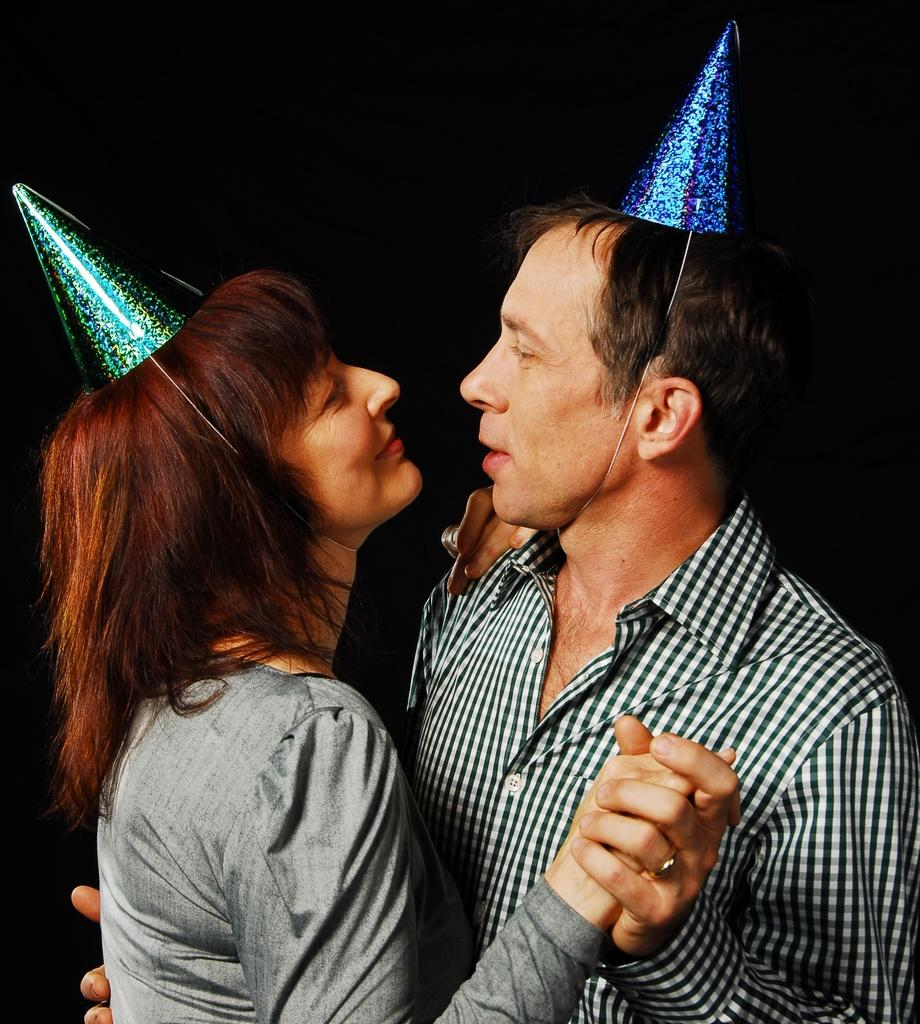How many people are in the image? There are two people standing in the image. What can be observed about the background of the image? The background of the image is dark. What type of scent can be detected in the image? There is no information about any scent in the image, so it cannot be determined from the image. 